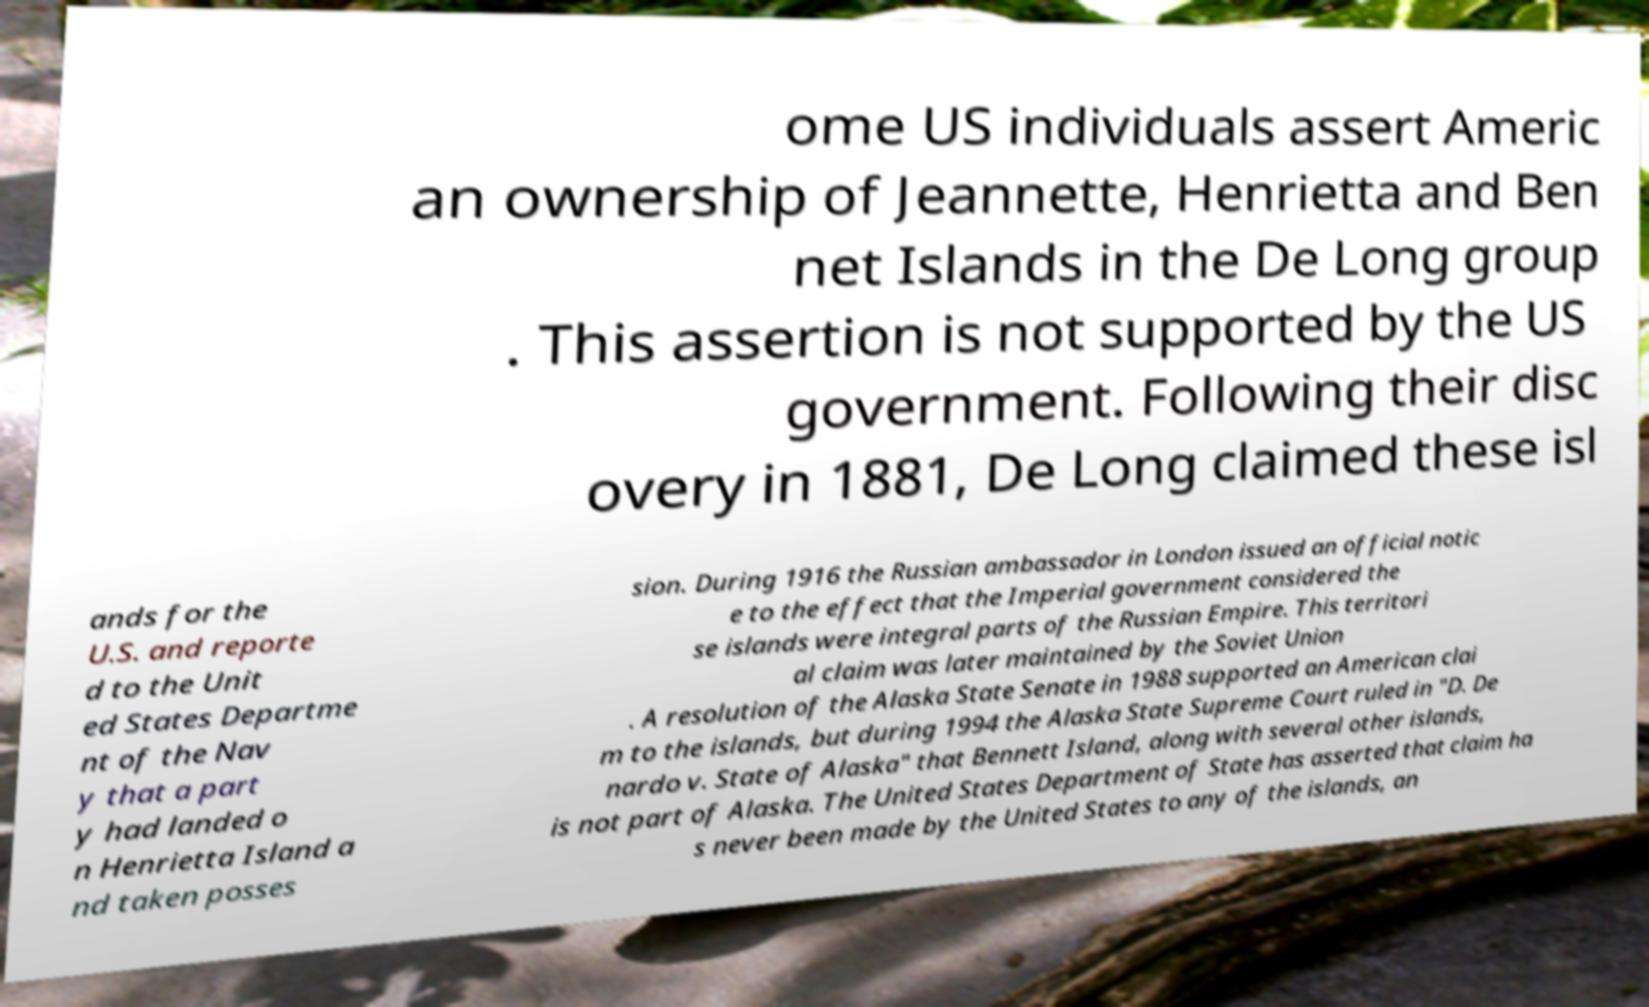There's text embedded in this image that I need extracted. Can you transcribe it verbatim? ome US individuals assert Americ an ownership of Jeannette, Henrietta and Ben net Islands in the De Long group . This assertion is not supported by the US government. Following their disc overy in 1881, De Long claimed these isl ands for the U.S. and reporte d to the Unit ed States Departme nt of the Nav y that a part y had landed o n Henrietta Island a nd taken posses sion. During 1916 the Russian ambassador in London issued an official notic e to the effect that the Imperial government considered the se islands were integral parts of the Russian Empire. This territori al claim was later maintained by the Soviet Union . A resolution of the Alaska State Senate in 1988 supported an American clai m to the islands, but during 1994 the Alaska State Supreme Court ruled in "D. De nardo v. State of Alaska" that Bennett Island, along with several other islands, is not part of Alaska. The United States Department of State has asserted that claim ha s never been made by the United States to any of the islands, an 